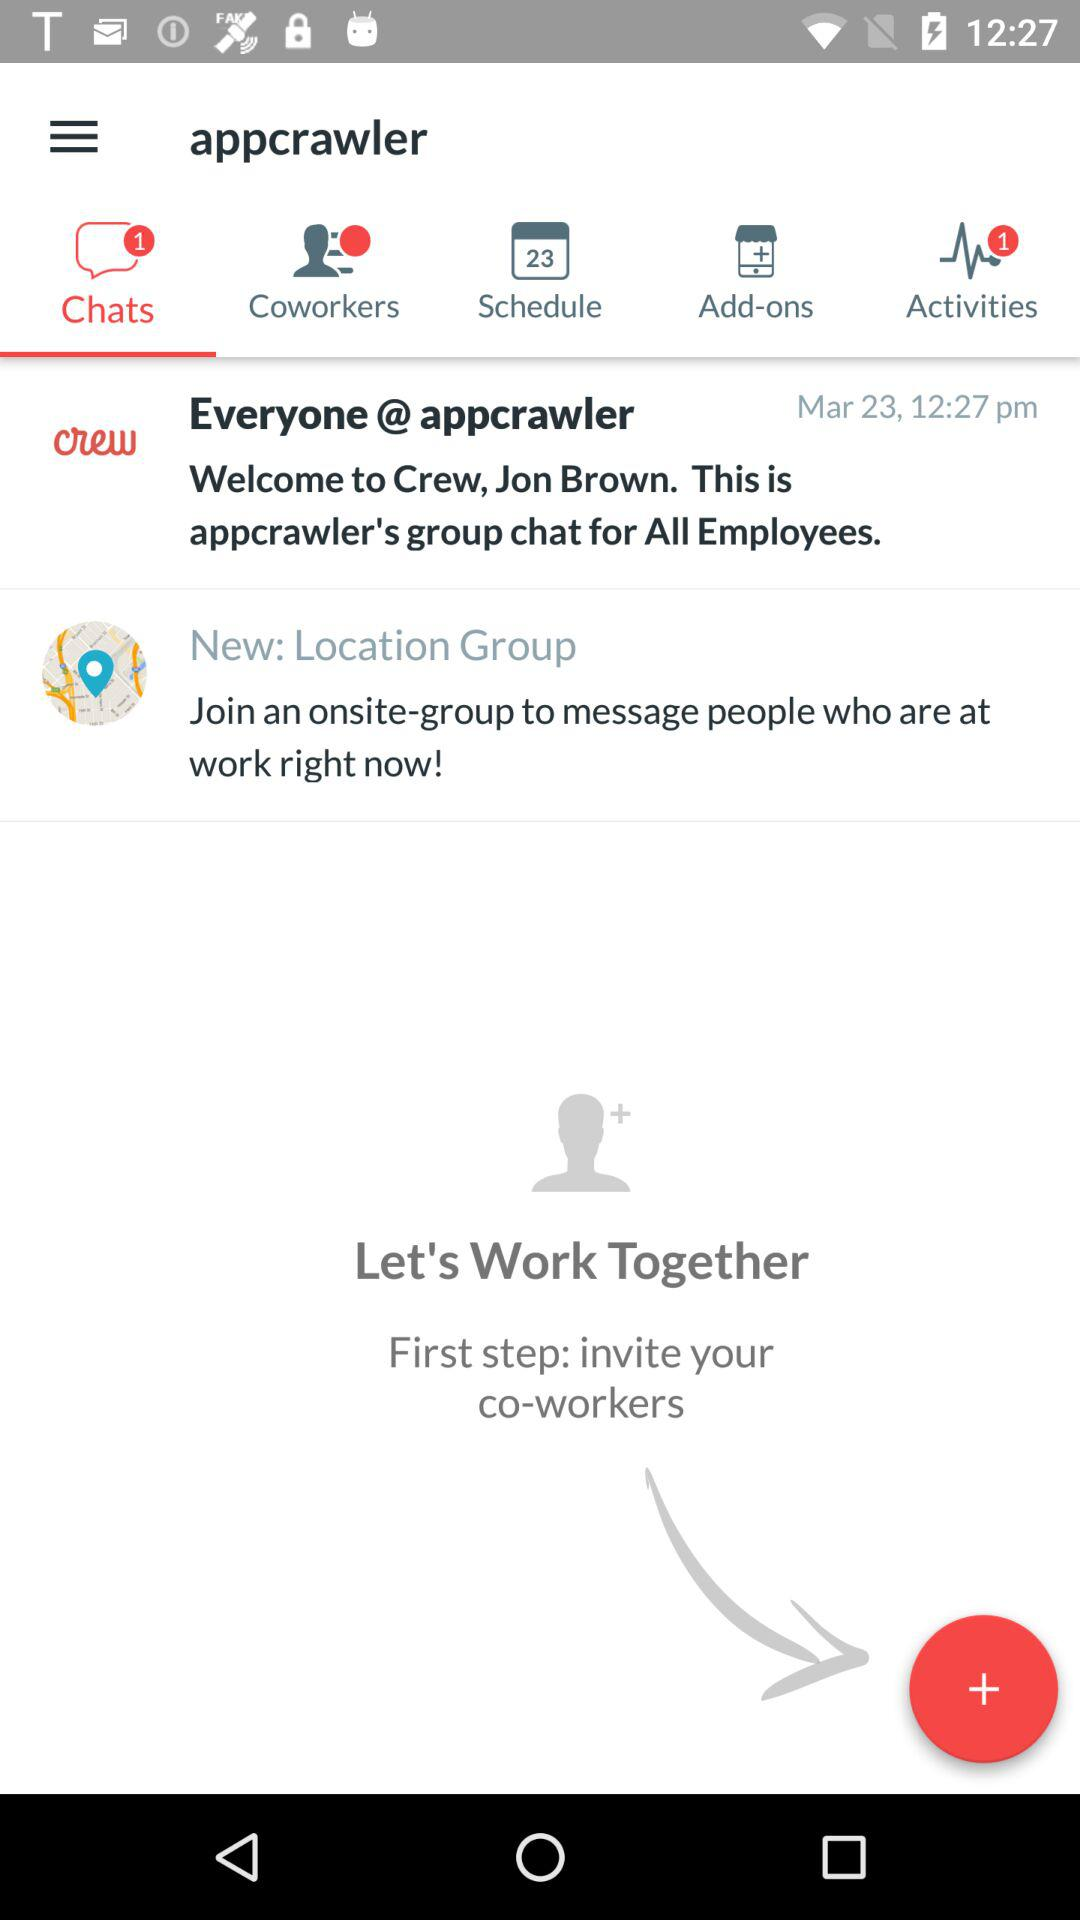How many notifications are pending on activities? There is one pending notification on activities. 